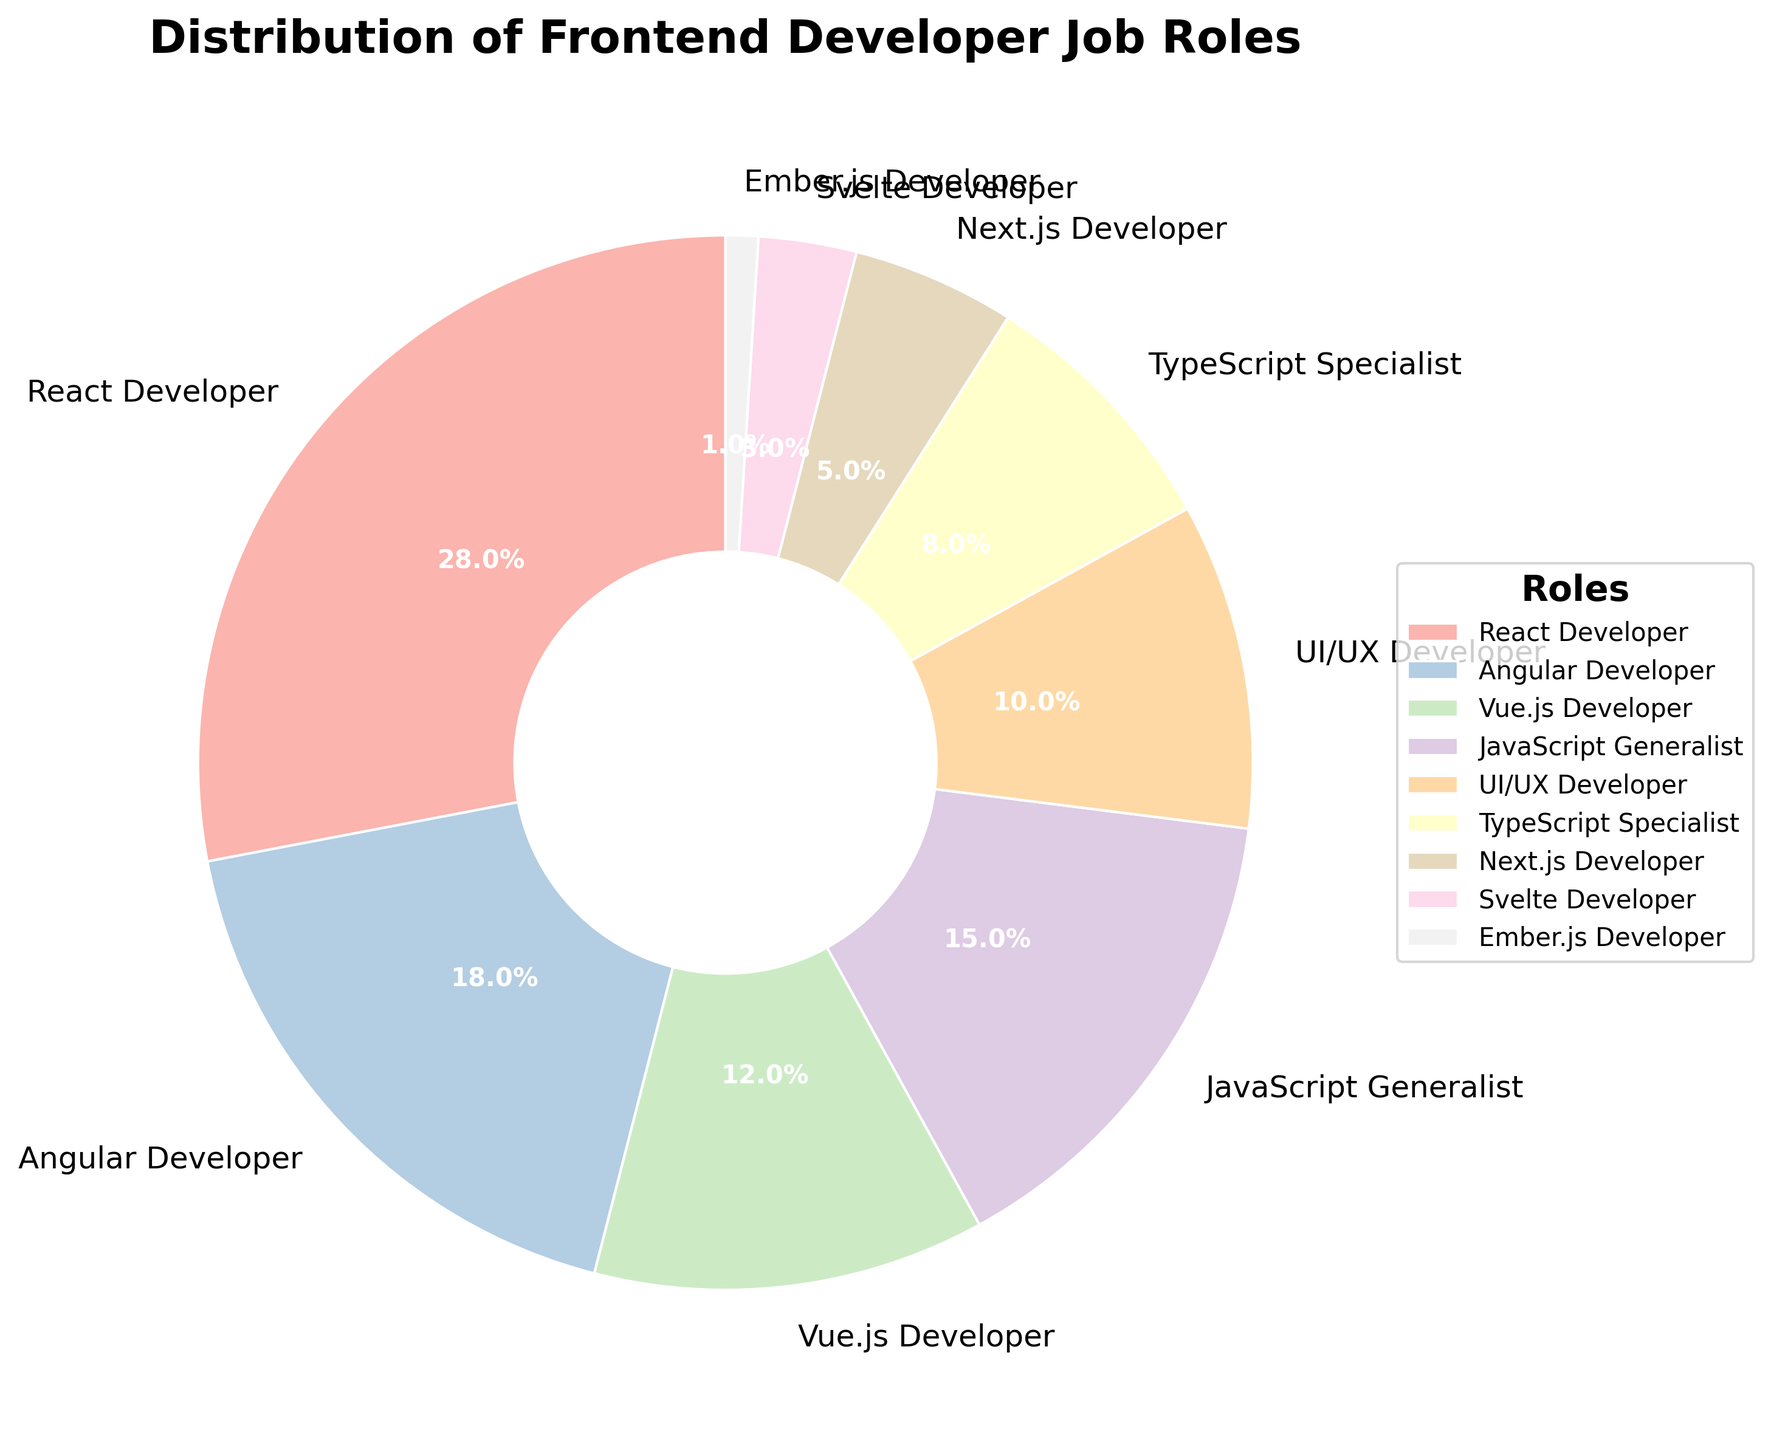What is the second most common frontend developer job role in the tech industry? Identify the job role with the second highest percentage from the chart. The chart indicates that the React Developer role is the most common at 28%, followed by the Angular Developer role at 18%.
Answer: Angular Developer Which frontend developer job role constitutes less than 5% of the distribution? Look for job roles with percentages less than 5% in the chart. The Next.js Developer (5%) is on the borderline, while Svelte Developer (3%) and Ember.js Developer (1%) are below 5%.
Answer: Svelte Developer and Ember.js Developer Compare the percentage of JavaScript Generalists and TypeScript Specialists. Which one is larger and by how much? Identify the percentages for JavaScript Generalists (15%) and TypeScript Specialists (8%) and then calculate the difference: 15% - 8% = 7%.
Answer: JavaScript Generalists are larger by 7% What is the combined percentage of UI/UX Developers and Next.js Developers? Identify the percentages for UI/UX Developers (10%) and Next.js Developers (5%) and then sum them: 10% + 5% = 15%.
Answer: 15% How many frontend developer job roles have a higher percentage than TypeScript Specialists? Identify roles with a percentage higher than TypeScript Specialists' 8%. These are React Developer, Angular Developer, Vue.js Developer, JavaScript Generalist, UI/UX Developer, and Next.js Developer, totaling 6.
Answer: 6 Which job role has the smallest representation and what percentage does it represent? Identify the job role with the smallest slice in the pie chart. The chart shows Ember.js Developer with the smallest percentage at 1%.
Answer: Ember.js Developer with 1% Is the percentage of Vue.js Developers greater or less than the combined percentage of Svelte and Ember.js Developers? Identify the percentage of Vue.js Developers (12%) and compare it with the sum of Svelte Developers (3%) and Ember.js Developers (1%): 12% vs. 4%.
Answer: Greater Which job role percentage is closest to the median of all job role percentages? Organize the percentages in ascending order: 1%, 3%, 5%, 8%, 10%, 12%, 15%, 18%, 28%. The median value is the middle number, which is 10%, corresponding to UI/UX Developers.
Answer: UI/UX Developer 